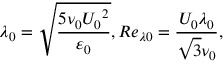<formula> <loc_0><loc_0><loc_500><loc_500>{ { \lambda } _ { 0 } } = \sqrt { \frac { 5 { { \nu } _ { 0 } } { { U } _ { 0 } } ^ { 2 } } { { { \varepsilon } _ { 0 } } } } , R { { e } _ { \lambda 0 } } = \frac { { { U } _ { 0 } } { { \lambda } _ { 0 } } } { \sqrt { 3 } { { \nu } _ { 0 } } } ,</formula> 